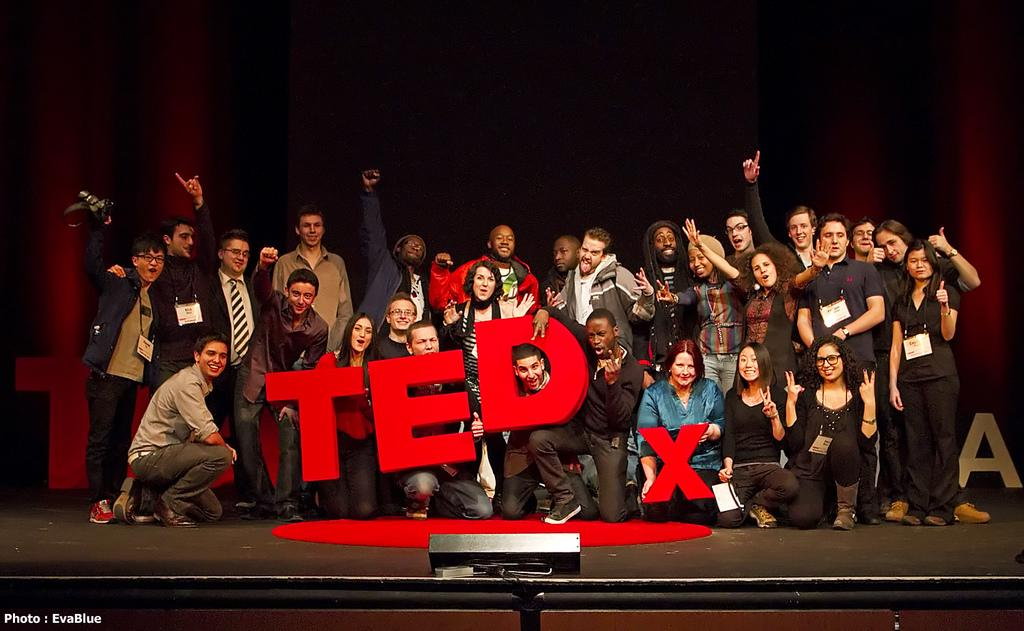How many people are present in the image? There are many people in the image. Where are the people located in the image? The people are on a dais. What are the people holding in the image? The people are holding TEDx signs. What is at the bottom of the image? There is a dais at the bottom of the image. What can be seen in the background of the image? There are curtains in the background of the image. How many tickets are visible in the image? There are no tickets visible in the image. What type of police presence can be seen in the image? There is no police presence in the image. 